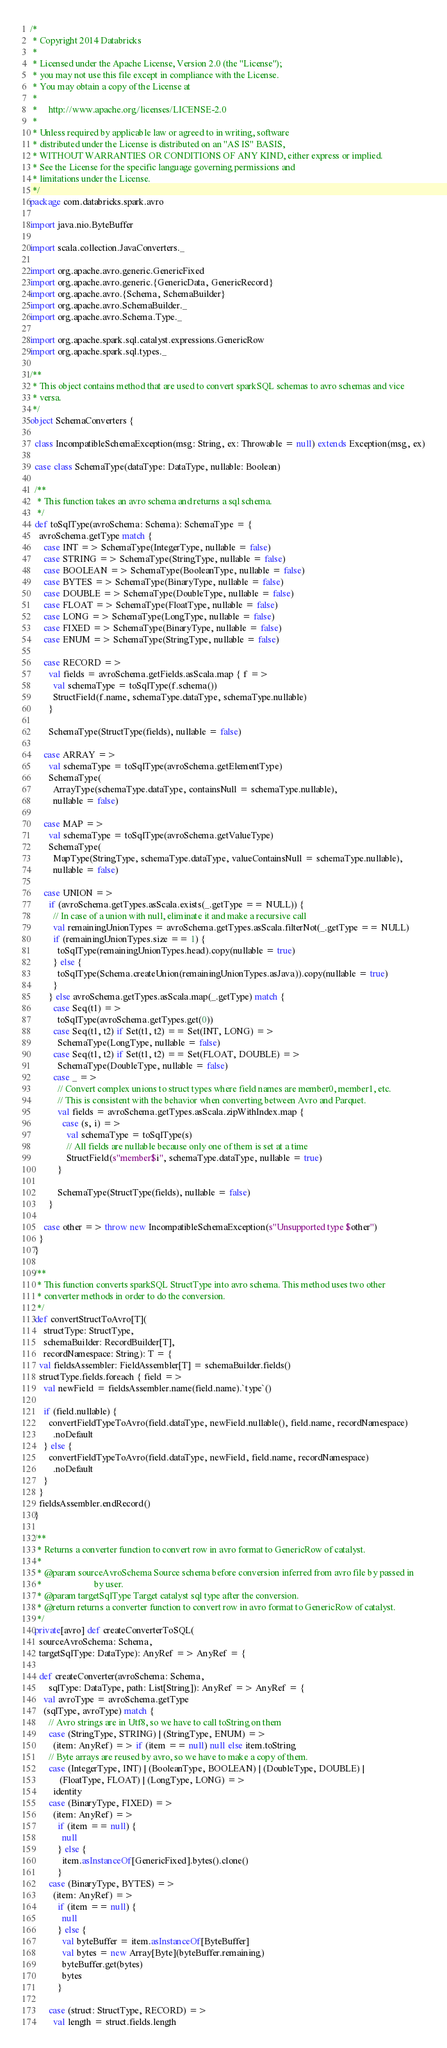Convert code to text. <code><loc_0><loc_0><loc_500><loc_500><_Scala_>/*
 * Copyright 2014 Databricks
 *
 * Licensed under the Apache License, Version 2.0 (the "License");
 * you may not use this file except in compliance with the License.
 * You may obtain a copy of the License at
 *
 *     http://www.apache.org/licenses/LICENSE-2.0
 *
 * Unless required by applicable law or agreed to in writing, software
 * distributed under the License is distributed on an "AS IS" BASIS,
 * WITHOUT WARRANTIES OR CONDITIONS OF ANY KIND, either express or implied.
 * See the License for the specific language governing permissions and
 * limitations under the License.
 */
package com.databricks.spark.avro

import java.nio.ByteBuffer

import scala.collection.JavaConverters._

import org.apache.avro.generic.GenericFixed
import org.apache.avro.generic.{GenericData, GenericRecord}
import org.apache.avro.{Schema, SchemaBuilder}
import org.apache.avro.SchemaBuilder._
import org.apache.avro.Schema.Type._

import org.apache.spark.sql.catalyst.expressions.GenericRow
import org.apache.spark.sql.types._

/**
 * This object contains method that are used to convert sparkSQL schemas to avro schemas and vice
 * versa.
 */
object SchemaConverters {

  class IncompatibleSchemaException(msg: String, ex: Throwable = null) extends Exception(msg, ex)

  case class SchemaType(dataType: DataType, nullable: Boolean)

  /**
   * This function takes an avro schema and returns a sql schema.
   */
  def toSqlType(avroSchema: Schema): SchemaType = {
    avroSchema.getType match {
      case INT => SchemaType(IntegerType, nullable = false)
      case STRING => SchemaType(StringType, nullable = false)
      case BOOLEAN => SchemaType(BooleanType, nullable = false)
      case BYTES => SchemaType(BinaryType, nullable = false)
      case DOUBLE => SchemaType(DoubleType, nullable = false)
      case FLOAT => SchemaType(FloatType, nullable = false)
      case LONG => SchemaType(LongType, nullable = false)
      case FIXED => SchemaType(BinaryType, nullable = false)
      case ENUM => SchemaType(StringType, nullable = false)

      case RECORD =>
        val fields = avroSchema.getFields.asScala.map { f =>
          val schemaType = toSqlType(f.schema())
          StructField(f.name, schemaType.dataType, schemaType.nullable)
        }

        SchemaType(StructType(fields), nullable = false)

      case ARRAY =>
        val schemaType = toSqlType(avroSchema.getElementType)
        SchemaType(
          ArrayType(schemaType.dataType, containsNull = schemaType.nullable),
          nullable = false)

      case MAP =>
        val schemaType = toSqlType(avroSchema.getValueType)
        SchemaType(
          MapType(StringType, schemaType.dataType, valueContainsNull = schemaType.nullable),
          nullable = false)

      case UNION =>
        if (avroSchema.getTypes.asScala.exists(_.getType == NULL)) {
          // In case of a union with null, eliminate it and make a recursive call
          val remainingUnionTypes = avroSchema.getTypes.asScala.filterNot(_.getType == NULL)
          if (remainingUnionTypes.size == 1) {
            toSqlType(remainingUnionTypes.head).copy(nullable = true)
          } else {
            toSqlType(Schema.createUnion(remainingUnionTypes.asJava)).copy(nullable = true)
          }
        } else avroSchema.getTypes.asScala.map(_.getType) match {
          case Seq(t1) =>
            toSqlType(avroSchema.getTypes.get(0))
          case Seq(t1, t2) if Set(t1, t2) == Set(INT, LONG) =>
            SchemaType(LongType, nullable = false)
          case Seq(t1, t2) if Set(t1, t2) == Set(FLOAT, DOUBLE) =>
            SchemaType(DoubleType, nullable = false)
          case _ =>
            // Convert complex unions to struct types where field names are member0, member1, etc.
            // This is consistent with the behavior when converting between Avro and Parquet.
            val fields = avroSchema.getTypes.asScala.zipWithIndex.map {
              case (s, i) =>
                val schemaType = toSqlType(s)
                // All fields are nullable because only one of them is set at a time
                StructField(s"member$i", schemaType.dataType, nullable = true)
            }

            SchemaType(StructType(fields), nullable = false)
        }

      case other => throw new IncompatibleSchemaException(s"Unsupported type $other")
    }
  }

  /**
   * This function converts sparkSQL StructType into avro schema. This method uses two other
   * converter methods in order to do the conversion.
   */
  def convertStructToAvro[T](
      structType: StructType,
      schemaBuilder: RecordBuilder[T],
      recordNamespace: String): T = {
    val fieldsAssembler: FieldAssembler[T] = schemaBuilder.fields()
    structType.fields.foreach { field =>
      val newField = fieldsAssembler.name(field.name).`type`()

      if (field.nullable) {
        convertFieldTypeToAvro(field.dataType, newField.nullable(), field.name, recordNamespace)
          .noDefault
      } else {
        convertFieldTypeToAvro(field.dataType, newField, field.name, recordNamespace)
          .noDefault
      }
    }
    fieldsAssembler.endRecord()
  }

  /**
   * Returns a converter function to convert row in avro format to GenericRow of catalyst.
   *
   * @param sourceAvroSchema Source schema before conversion inferred from avro file by passed in
   *                       by user.
   * @param targetSqlType Target catalyst sql type after the conversion.
   * @return returns a converter function to convert row in avro format to GenericRow of catalyst.
   */
  private[avro] def createConverterToSQL(
    sourceAvroSchema: Schema,
    targetSqlType: DataType): AnyRef => AnyRef = {

    def createConverter(avroSchema: Schema,
        sqlType: DataType, path: List[String]): AnyRef => AnyRef = {
      val avroType = avroSchema.getType
      (sqlType, avroType) match {
        // Avro strings are in Utf8, so we have to call toString on them
        case (StringType, STRING) | (StringType, ENUM) =>
          (item: AnyRef) => if (item == null) null else item.toString
        // Byte arrays are reused by avro, so we have to make a copy of them.
        case (IntegerType, INT) | (BooleanType, BOOLEAN) | (DoubleType, DOUBLE) |
             (FloatType, FLOAT) | (LongType, LONG) =>
          identity
        case (BinaryType, FIXED) =>
          (item: AnyRef) =>
            if (item == null) {
              null
            } else {
              item.asInstanceOf[GenericFixed].bytes().clone()
            }
        case (BinaryType, BYTES) =>
          (item: AnyRef) =>
            if (item == null) {
              null
            } else {
              val byteBuffer = item.asInstanceOf[ByteBuffer]
              val bytes = new Array[Byte](byteBuffer.remaining)
              byteBuffer.get(bytes)
              bytes
            }

        case (struct: StructType, RECORD) =>
          val length = struct.fields.length</code> 